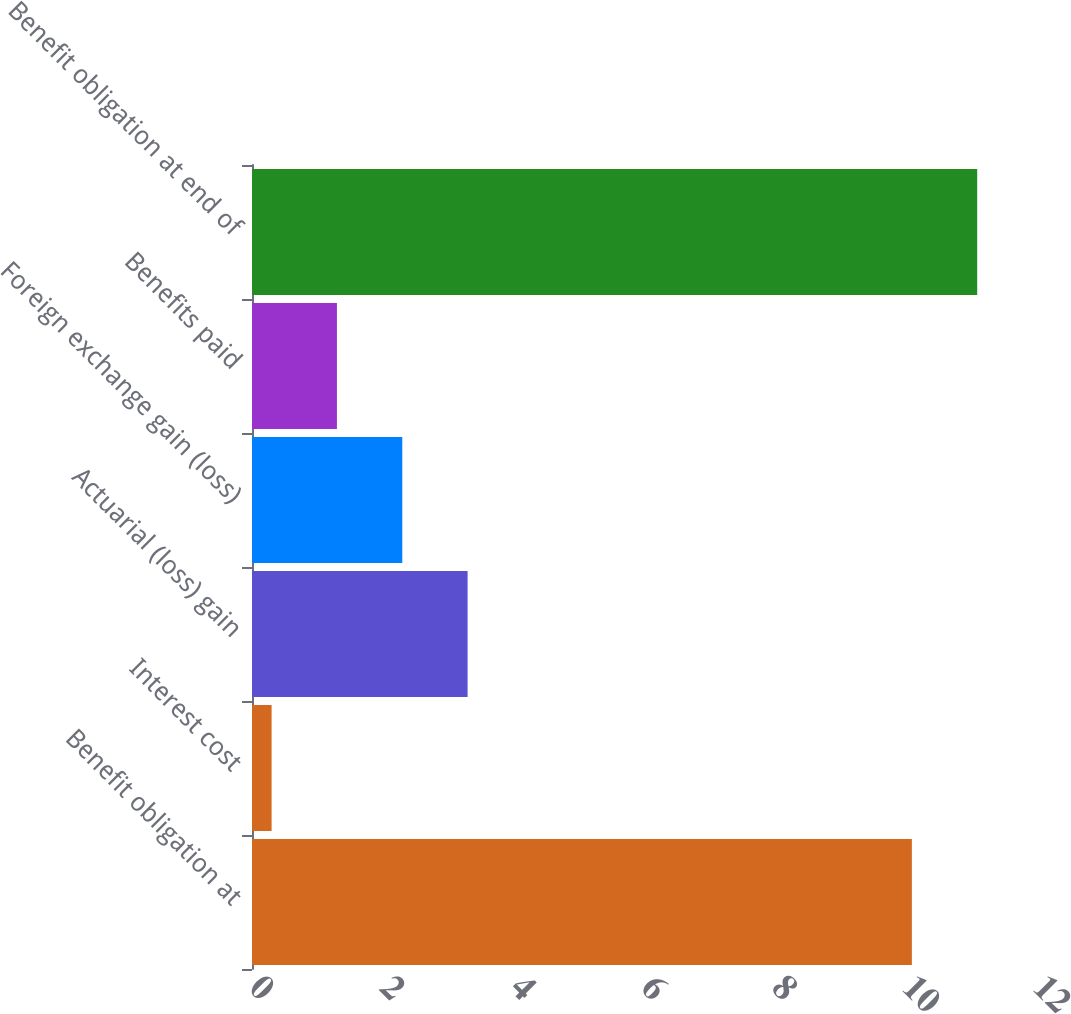Convert chart. <chart><loc_0><loc_0><loc_500><loc_500><bar_chart><fcel>Benefit obligation at<fcel>Interest cost<fcel>Actuarial (loss) gain<fcel>Foreign exchange gain (loss)<fcel>Benefits paid<fcel>Benefit obligation at end of<nl><fcel>10.1<fcel>0.3<fcel>3.3<fcel>2.3<fcel>1.3<fcel>11.1<nl></chart> 